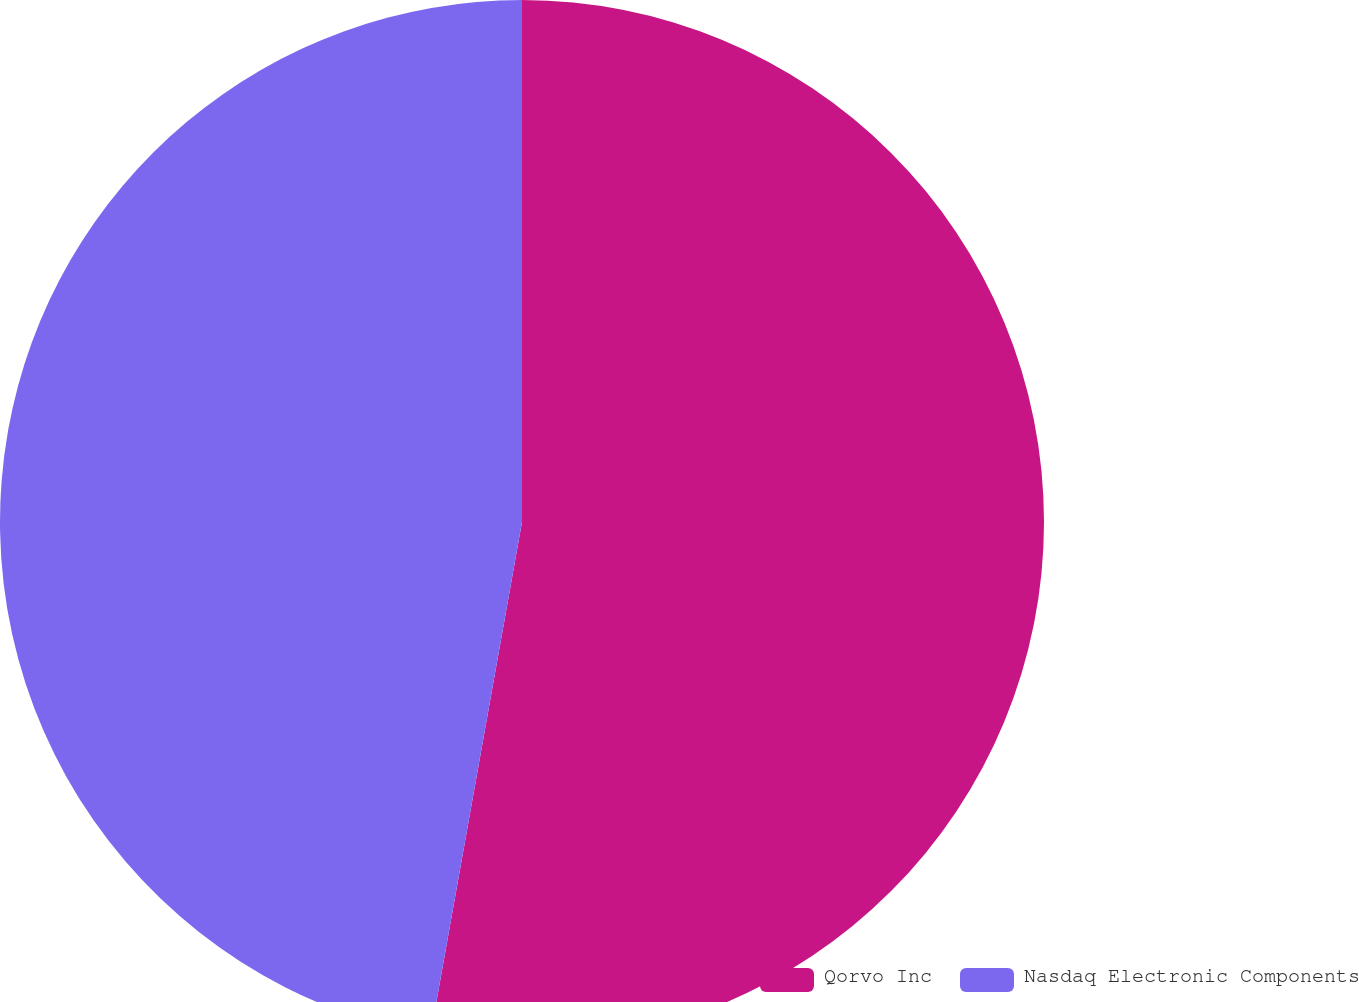Convert chart to OTSL. <chart><loc_0><loc_0><loc_500><loc_500><pie_chart><fcel>Qorvo Inc<fcel>Nasdaq Electronic Components<nl><fcel>52.81%<fcel>47.19%<nl></chart> 